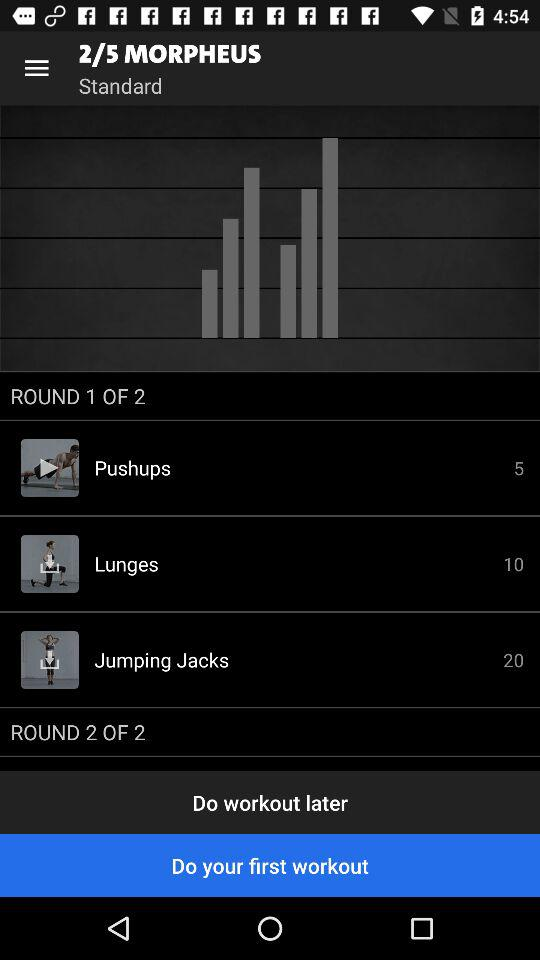How many rounds are there in this workout?
Answer the question using a single word or phrase. 2 